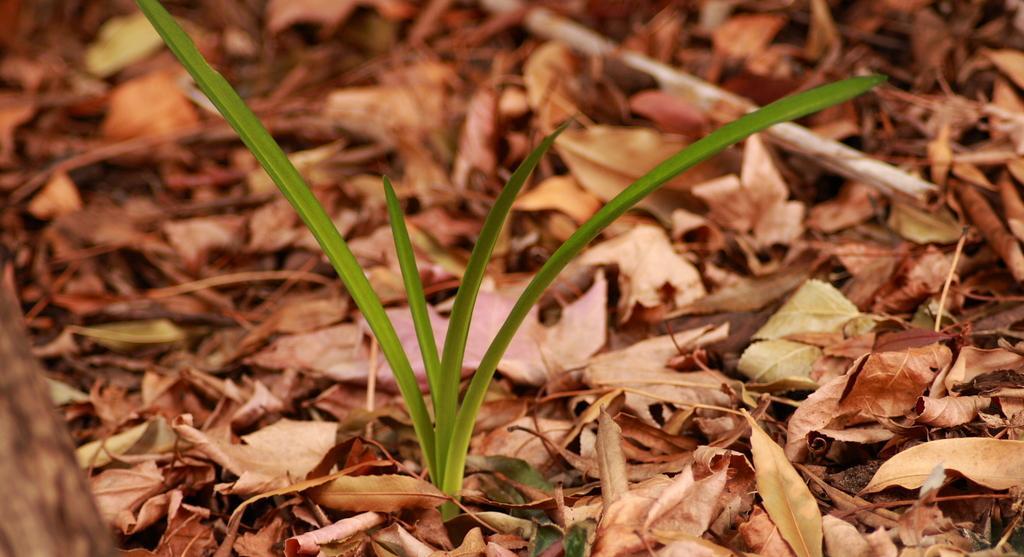Could you give a brief overview of what you see in this image? We can see plant and leaves. 